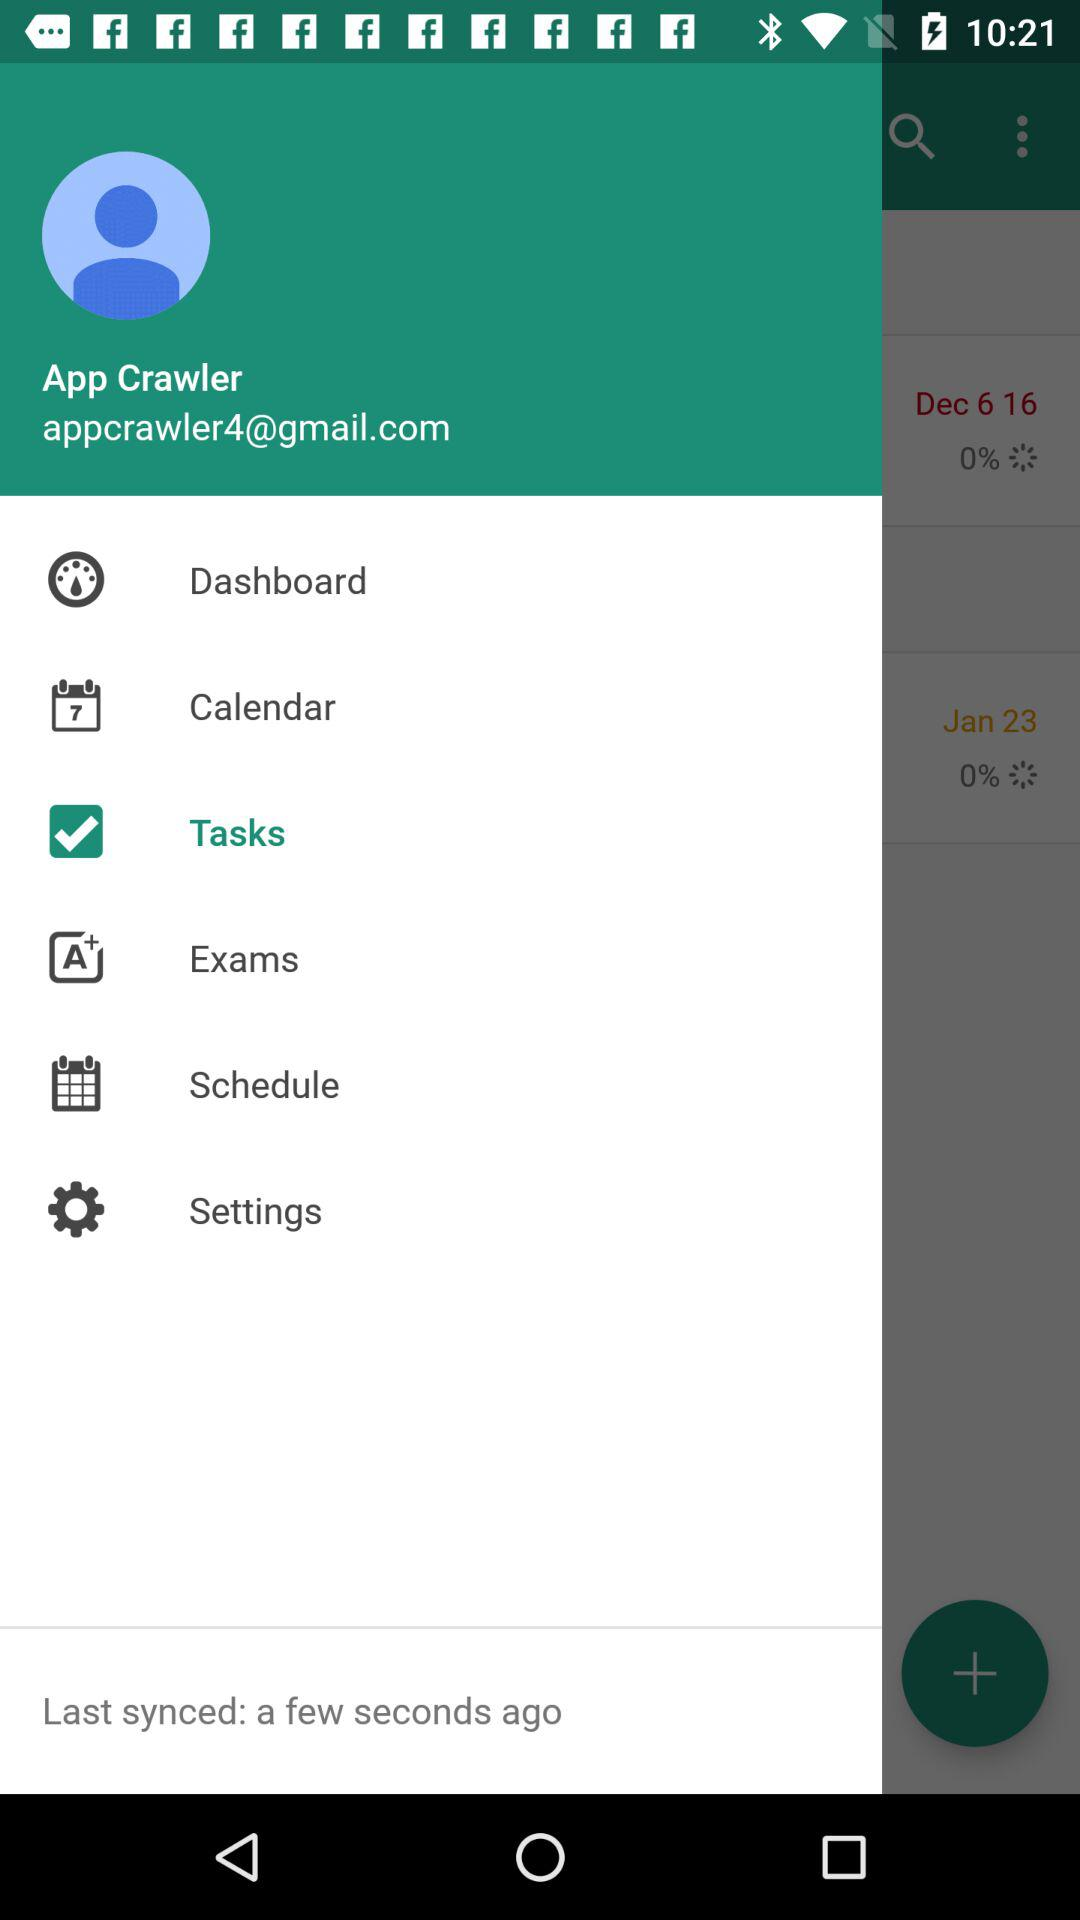What is the user name? The user name is App Crawler. 